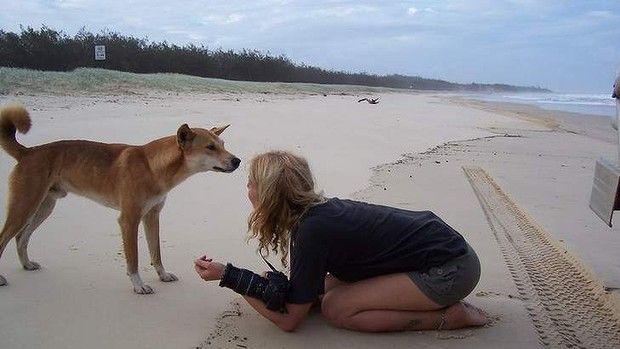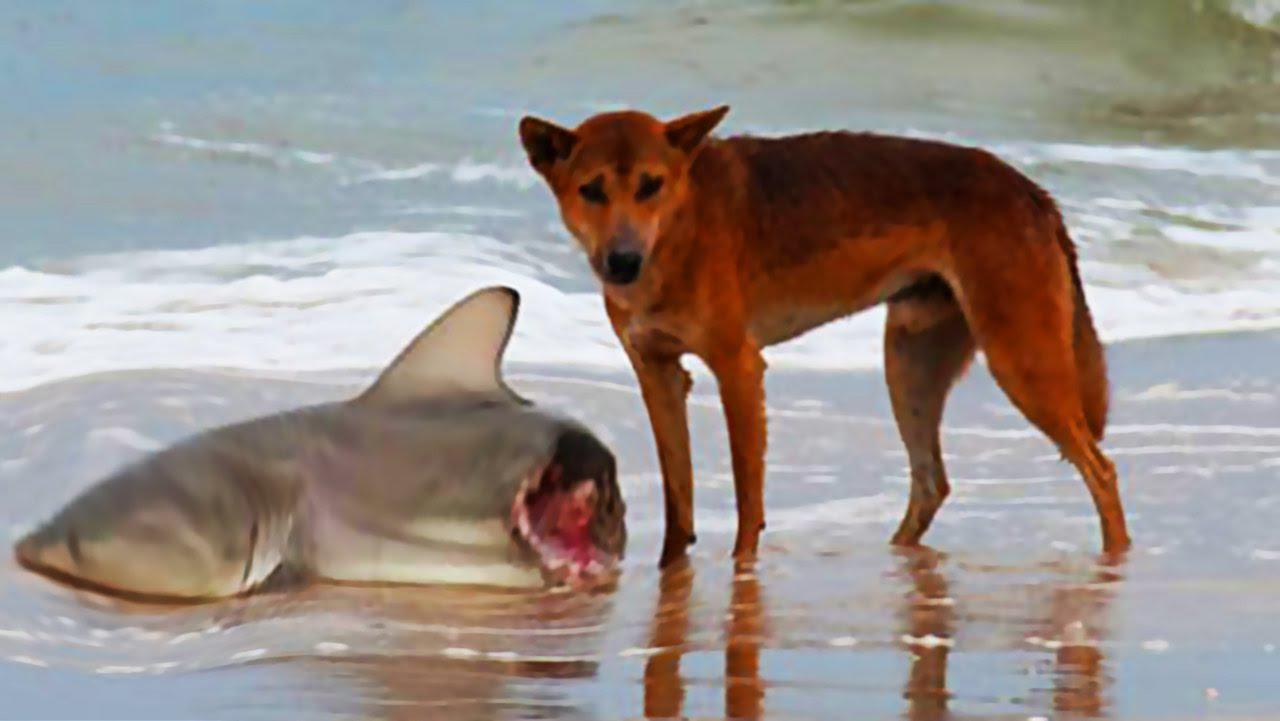The first image is the image on the left, the second image is the image on the right. Analyze the images presented: Is the assertion "The right image contains a dog on the beach next to a dead shark." valid? Answer yes or no. Yes. The first image is the image on the left, the second image is the image on the right. For the images displayed, is the sentence "An image shows a person in some pose to the right of a standing orange dog." factually correct? Answer yes or no. Yes. 